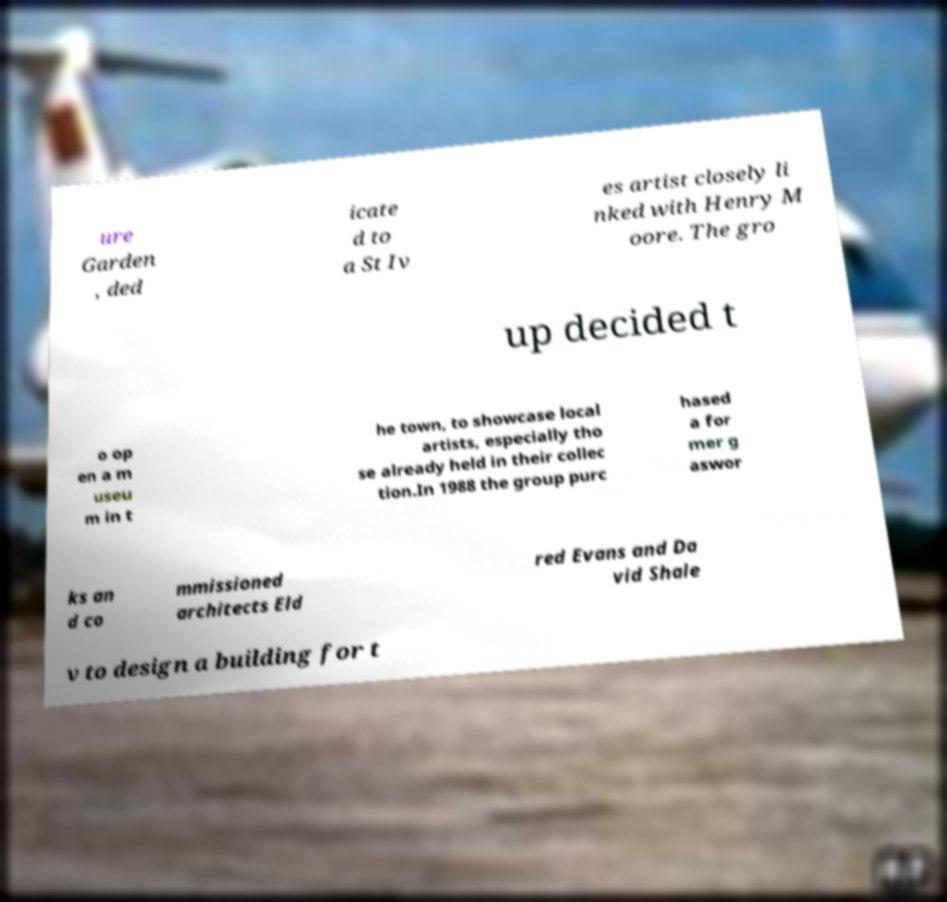Can you read and provide the text displayed in the image?This photo seems to have some interesting text. Can you extract and type it out for me? ure Garden , ded icate d to a St Iv es artist closely li nked with Henry M oore. The gro up decided t o op en a m useu m in t he town, to showcase local artists, especially tho se already held in their collec tion.In 1988 the group purc hased a for mer g aswor ks an d co mmissioned architects Eld red Evans and Da vid Shale v to design a building for t 